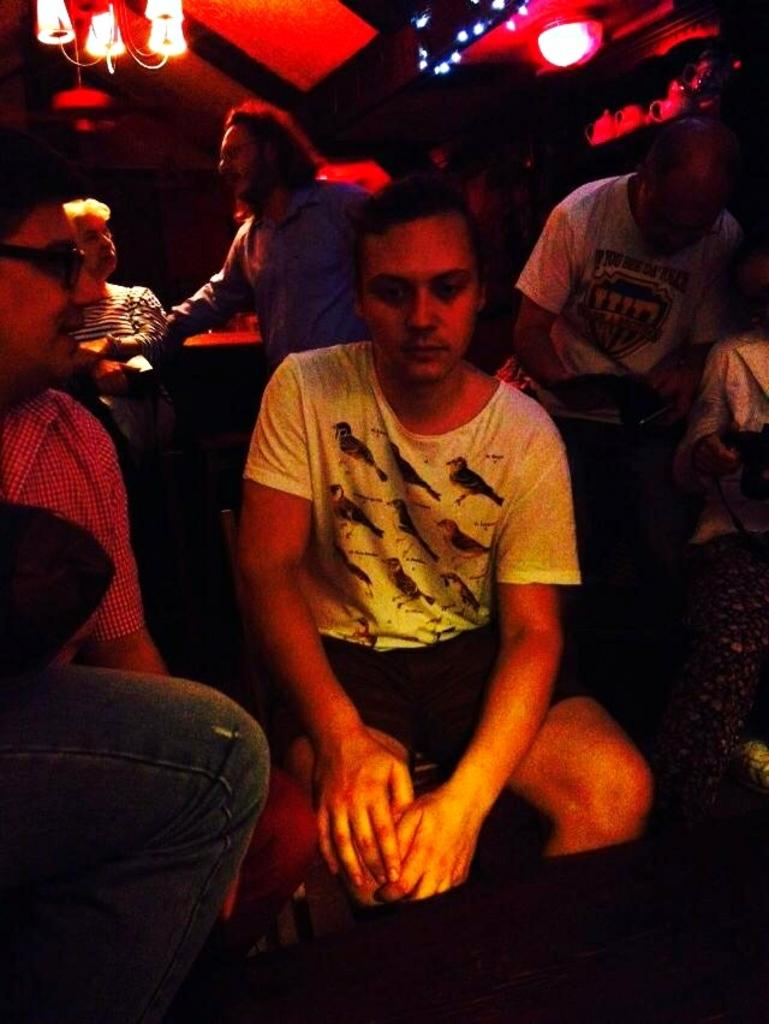What is the main subject in the center of the image? There is a person sitting in the center of the image. Can you describe the people on the right side of the image? There are persons on the right side of the image. What about the people on the left side of the image? There are persons on the left side of the image as well. What can be seen in the background of the image? There is a table and lights in the background of the image. What type of alarm is going off in the image? There is no alarm present in the image. Can you tell me how the person sitting in the center is related to the person on the left side of the image? The provided facts do not give any information about the relationships between the people in the image. 